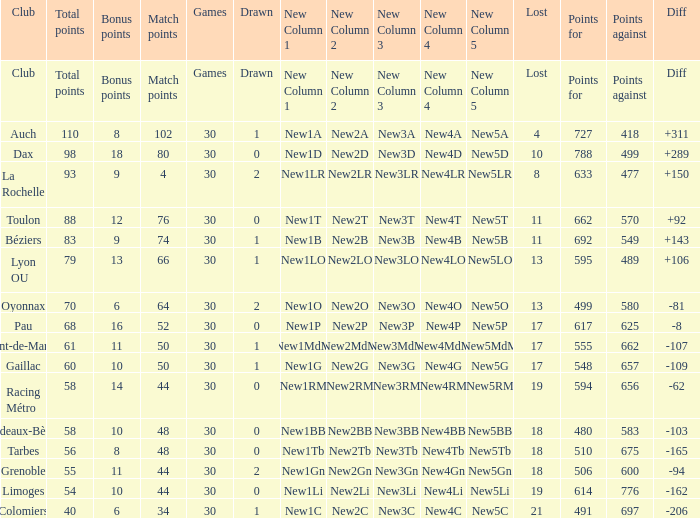Give me the full table as a dictionary. {'header': ['Club', 'Total points', 'Bonus points', 'Match points', 'Games', 'Drawn', 'New Column 1', 'New Column 2', 'New Column 3', 'New Column 4', 'New Column 5', 'Lost', 'Points for', 'Points against', 'Diff'], 'rows': [['Club', 'Total points', 'Bonus points', 'Match points', 'Games', 'Drawn', 'New Column 1', 'New Column 2', 'New Column 3', 'New Column 4', 'New Column 5', 'Lost', 'Points for', 'Points against', 'Diff'], ['Auch', '110', '8', '102', '30', '1', 'New1A', 'New2A', 'New3A', 'New4A', 'New5A', '4', '727', '418', '+311'], ['Dax', '98', '18', '80', '30', '0', 'New1D', 'New2D', 'New3D', 'New4D', 'New5D', '10', '788', '499', '+289'], ['La Rochelle', '93', '9', '4', '30', '2', 'New1LR', 'New2LR', 'New3LR', 'New4LR', 'New5LR', '8', '633', '477', '+150'], ['Toulon', '88', '12', '76', '30', '0', 'New1T', 'New2T', 'New3T', 'New4T', 'New5T', '11', '662', '570', '+92'], ['Béziers', '83', '9', '74', '30', '1', 'New1B', 'New2B', 'New3B', 'New4B', 'New5B', '11', '692', '549', '+143'], ['Lyon OU', '79', '13', '66', '30', '1', 'New1LO', 'New2LO', 'New3LO', 'New4LO', 'New5LO', '13', '595', '489', '+106'], ['Oyonnax', '70', '6', '64', '30', '2', 'New1O', 'New2O', 'New3O', 'New4O', 'New5O', '13', '499', '580', '-81'], ['Pau', '68', '16', '52', '30', '0', 'New1P', 'New2P', 'New3P', 'New4P', 'New5P', '17', '617', '625', '-8'], ['Mont-de-Marsan', '61', '11', '50', '30', '1', 'New1MdM', 'New2MdM', 'New3MdM', 'New4MdM', 'New5MdM', '17', '555', '662', '-107'], ['Gaillac', '60', '10', '50', '30', '1', 'New1G', 'New2G', 'New3G', 'New4G', 'New5G', '17', '548', '657', '-109'], ['Racing Métro', '58', '14', '44', '30', '0', 'New1RM', 'New2RM', 'New3RM', 'New4RM', 'New5RM', '19', '594', '656', '-62'], ['Bordeaux-Bègles', '58', '10', '48', '30', '0', 'New1BB', 'New2BB', 'New3BB', 'New4BB', 'New5BB', '18', '480', '583', '-103'], ['Tarbes', '56', '8', '48', '30', '0', 'New1Tb', 'New2Tb', 'New3Tb', 'New4Tb', 'New5Tb', '18', '510', '675', '-165'], ['Grenoble', '55', '11', '44', '30', '2', 'New1Gn', 'New2Gn', 'New3Gn', 'New4Gn', 'New5Gn', '18', '506', '600', '-94'], ['Limoges', '54', '10', '44', '30', '0', 'New1Li', 'New2Li', 'New3Li', 'New4Li', 'New5Li', '19', '614', '776', '-162'], ['Colomiers', '40', '6', '34', '30', '1', 'New1C', 'New2C', 'New3C', 'New4C', 'New5C', '21', '491', '697', '-206']]} What is the value of match points when the points for is 570? 76.0. 